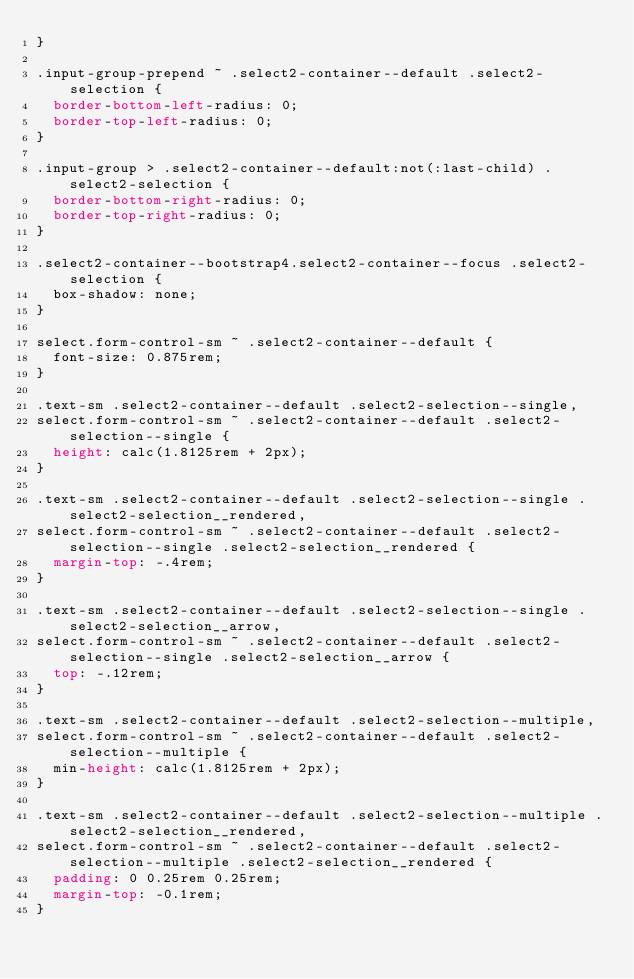<code> <loc_0><loc_0><loc_500><loc_500><_CSS_>}

.input-group-prepend ~ .select2-container--default .select2-selection {
  border-bottom-left-radius: 0;
  border-top-left-radius: 0;
}

.input-group > .select2-container--default:not(:last-child) .select2-selection {
  border-bottom-right-radius: 0;
  border-top-right-radius: 0;
}

.select2-container--bootstrap4.select2-container--focus .select2-selection {
  box-shadow: none;
}

select.form-control-sm ~ .select2-container--default {
  font-size: 0.875rem;
}

.text-sm .select2-container--default .select2-selection--single,
select.form-control-sm ~ .select2-container--default .select2-selection--single {
  height: calc(1.8125rem + 2px);
}

.text-sm .select2-container--default .select2-selection--single .select2-selection__rendered,
select.form-control-sm ~ .select2-container--default .select2-selection--single .select2-selection__rendered {
  margin-top: -.4rem;
}

.text-sm .select2-container--default .select2-selection--single .select2-selection__arrow,
select.form-control-sm ~ .select2-container--default .select2-selection--single .select2-selection__arrow {
  top: -.12rem;
}

.text-sm .select2-container--default .select2-selection--multiple,
select.form-control-sm ~ .select2-container--default .select2-selection--multiple {
  min-height: calc(1.8125rem + 2px);
}

.text-sm .select2-container--default .select2-selection--multiple .select2-selection__rendered,
select.form-control-sm ~ .select2-container--default .select2-selection--multiple .select2-selection__rendered {
  padding: 0 0.25rem 0.25rem;
  margin-top: -0.1rem;
}
</code> 